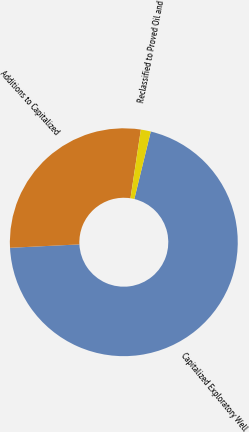Convert chart. <chart><loc_0><loc_0><loc_500><loc_500><pie_chart><fcel>Capitalized Exploratory Well<fcel>Additions to Capitalized<fcel>Reclassified to Proved Oil and<nl><fcel>70.42%<fcel>28.17%<fcel>1.41%<nl></chart> 